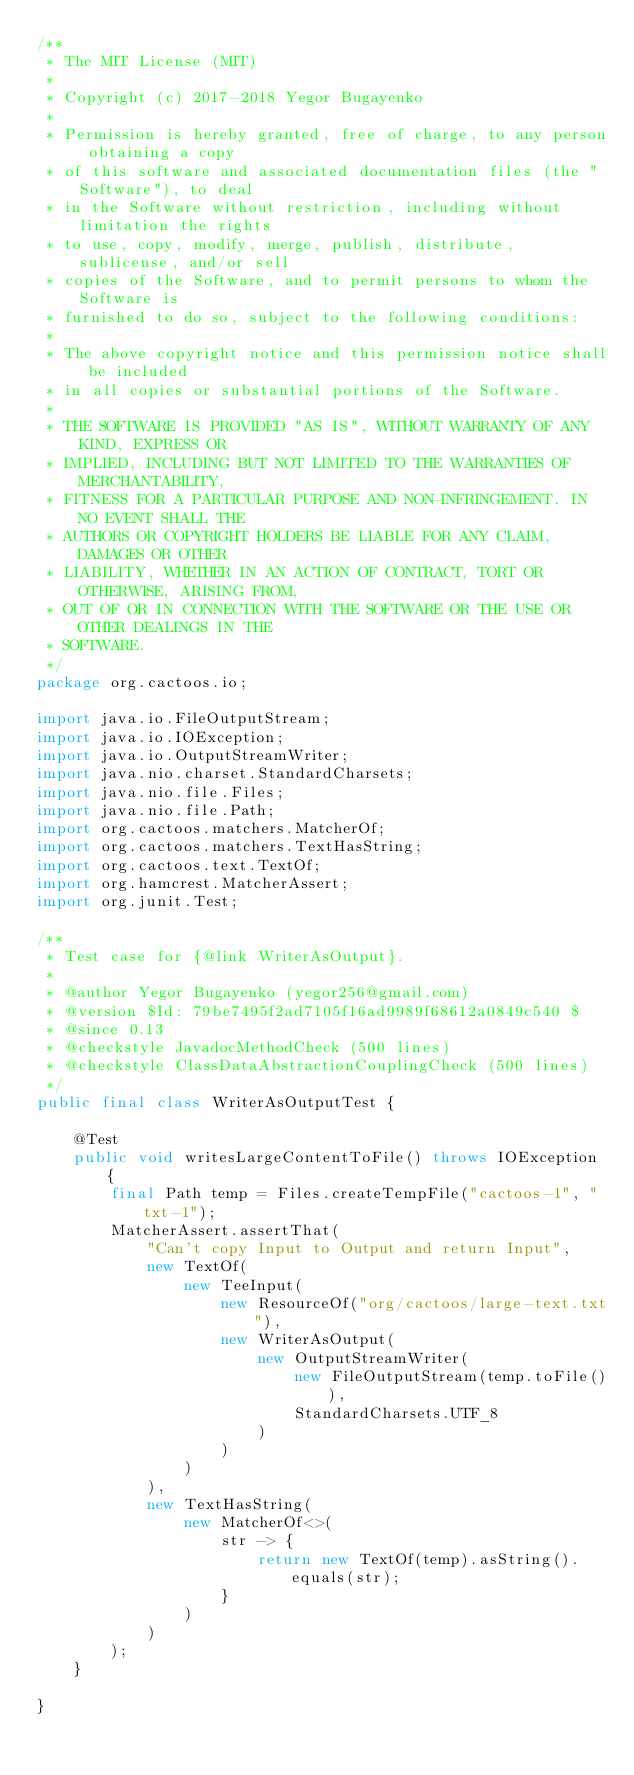Convert code to text. <code><loc_0><loc_0><loc_500><loc_500><_Java_>/**
 * The MIT License (MIT)
 *
 * Copyright (c) 2017-2018 Yegor Bugayenko
 *
 * Permission is hereby granted, free of charge, to any person obtaining a copy
 * of this software and associated documentation files (the "Software"), to deal
 * in the Software without restriction, including without limitation the rights
 * to use, copy, modify, merge, publish, distribute, sublicense, and/or sell
 * copies of the Software, and to permit persons to whom the Software is
 * furnished to do so, subject to the following conditions:
 *
 * The above copyright notice and this permission notice shall be included
 * in all copies or substantial portions of the Software.
 *
 * THE SOFTWARE IS PROVIDED "AS IS", WITHOUT WARRANTY OF ANY KIND, EXPRESS OR
 * IMPLIED, INCLUDING BUT NOT LIMITED TO THE WARRANTIES OF MERCHANTABILITY,
 * FITNESS FOR A PARTICULAR PURPOSE AND NON-INFRINGEMENT. IN NO EVENT SHALL THE
 * AUTHORS OR COPYRIGHT HOLDERS BE LIABLE FOR ANY CLAIM, DAMAGES OR OTHER
 * LIABILITY, WHETHER IN AN ACTION OF CONTRACT, TORT OR OTHERWISE, ARISING FROM,
 * OUT OF OR IN CONNECTION WITH THE SOFTWARE OR THE USE OR OTHER DEALINGS IN THE
 * SOFTWARE.
 */
package org.cactoos.io;

import java.io.FileOutputStream;
import java.io.IOException;
import java.io.OutputStreamWriter;
import java.nio.charset.StandardCharsets;
import java.nio.file.Files;
import java.nio.file.Path;
import org.cactoos.matchers.MatcherOf;
import org.cactoos.matchers.TextHasString;
import org.cactoos.text.TextOf;
import org.hamcrest.MatcherAssert;
import org.junit.Test;

/**
 * Test case for {@link WriterAsOutput}.
 *
 * @author Yegor Bugayenko (yegor256@gmail.com)
 * @version $Id: 79be7495f2ad7105f16ad9989f68612a0849c540 $
 * @since 0.13
 * @checkstyle JavadocMethodCheck (500 lines)
 * @checkstyle ClassDataAbstractionCouplingCheck (500 lines)
 */
public final class WriterAsOutputTest {

    @Test
    public void writesLargeContentToFile() throws IOException {
        final Path temp = Files.createTempFile("cactoos-1", "txt-1");
        MatcherAssert.assertThat(
            "Can't copy Input to Output and return Input",
            new TextOf(
                new TeeInput(
                    new ResourceOf("org/cactoos/large-text.txt"),
                    new WriterAsOutput(
                        new OutputStreamWriter(
                            new FileOutputStream(temp.toFile()),
                            StandardCharsets.UTF_8
                        )
                    )
                )
            ),
            new TextHasString(
                new MatcherOf<>(
                    str -> {
                        return new TextOf(temp).asString().equals(str);
                    }
                )
            )
        );
    }

}
</code> 